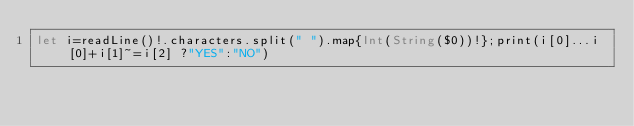Convert code to text. <code><loc_0><loc_0><loc_500><loc_500><_Swift_>let i=readLine()!.characters.split(" ").map{Int(String($0))!};print(i[0]...i[0]+i[1]~=i[2] ?"YES":"NO")</code> 